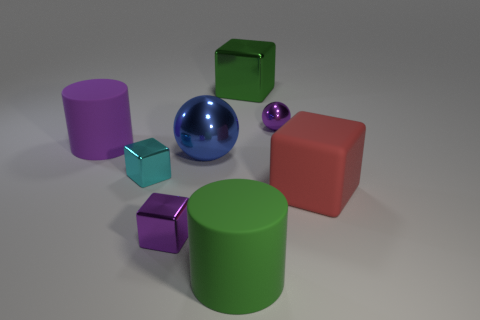Do the cyan cube and the red matte cube have the same size?
Give a very brief answer. No. Is there any other thing that has the same color as the matte cube?
Ensure brevity in your answer.  No. The object that is to the right of the blue metal object and in front of the matte cube has what shape?
Your response must be concise. Cylinder. There is a rubber thing to the right of the big shiny cube; what size is it?
Keep it short and to the point. Large. How many purple shiny objects are to the right of the large cube that is on the left side of the tiny purple object that is behind the small purple metal block?
Ensure brevity in your answer.  1. There is a large sphere; are there any big blue spheres right of it?
Keep it short and to the point. No. What number of other things are the same size as the green metallic cube?
Your answer should be very brief. 4. What is the material of the purple object that is both behind the red matte object and on the left side of the big metallic cube?
Your answer should be compact. Rubber. Does the big green object that is behind the red block have the same shape as the purple shiny thing on the left side of the big blue sphere?
Provide a short and direct response. Yes. Is there anything else that is made of the same material as the large blue ball?
Give a very brief answer. Yes. 